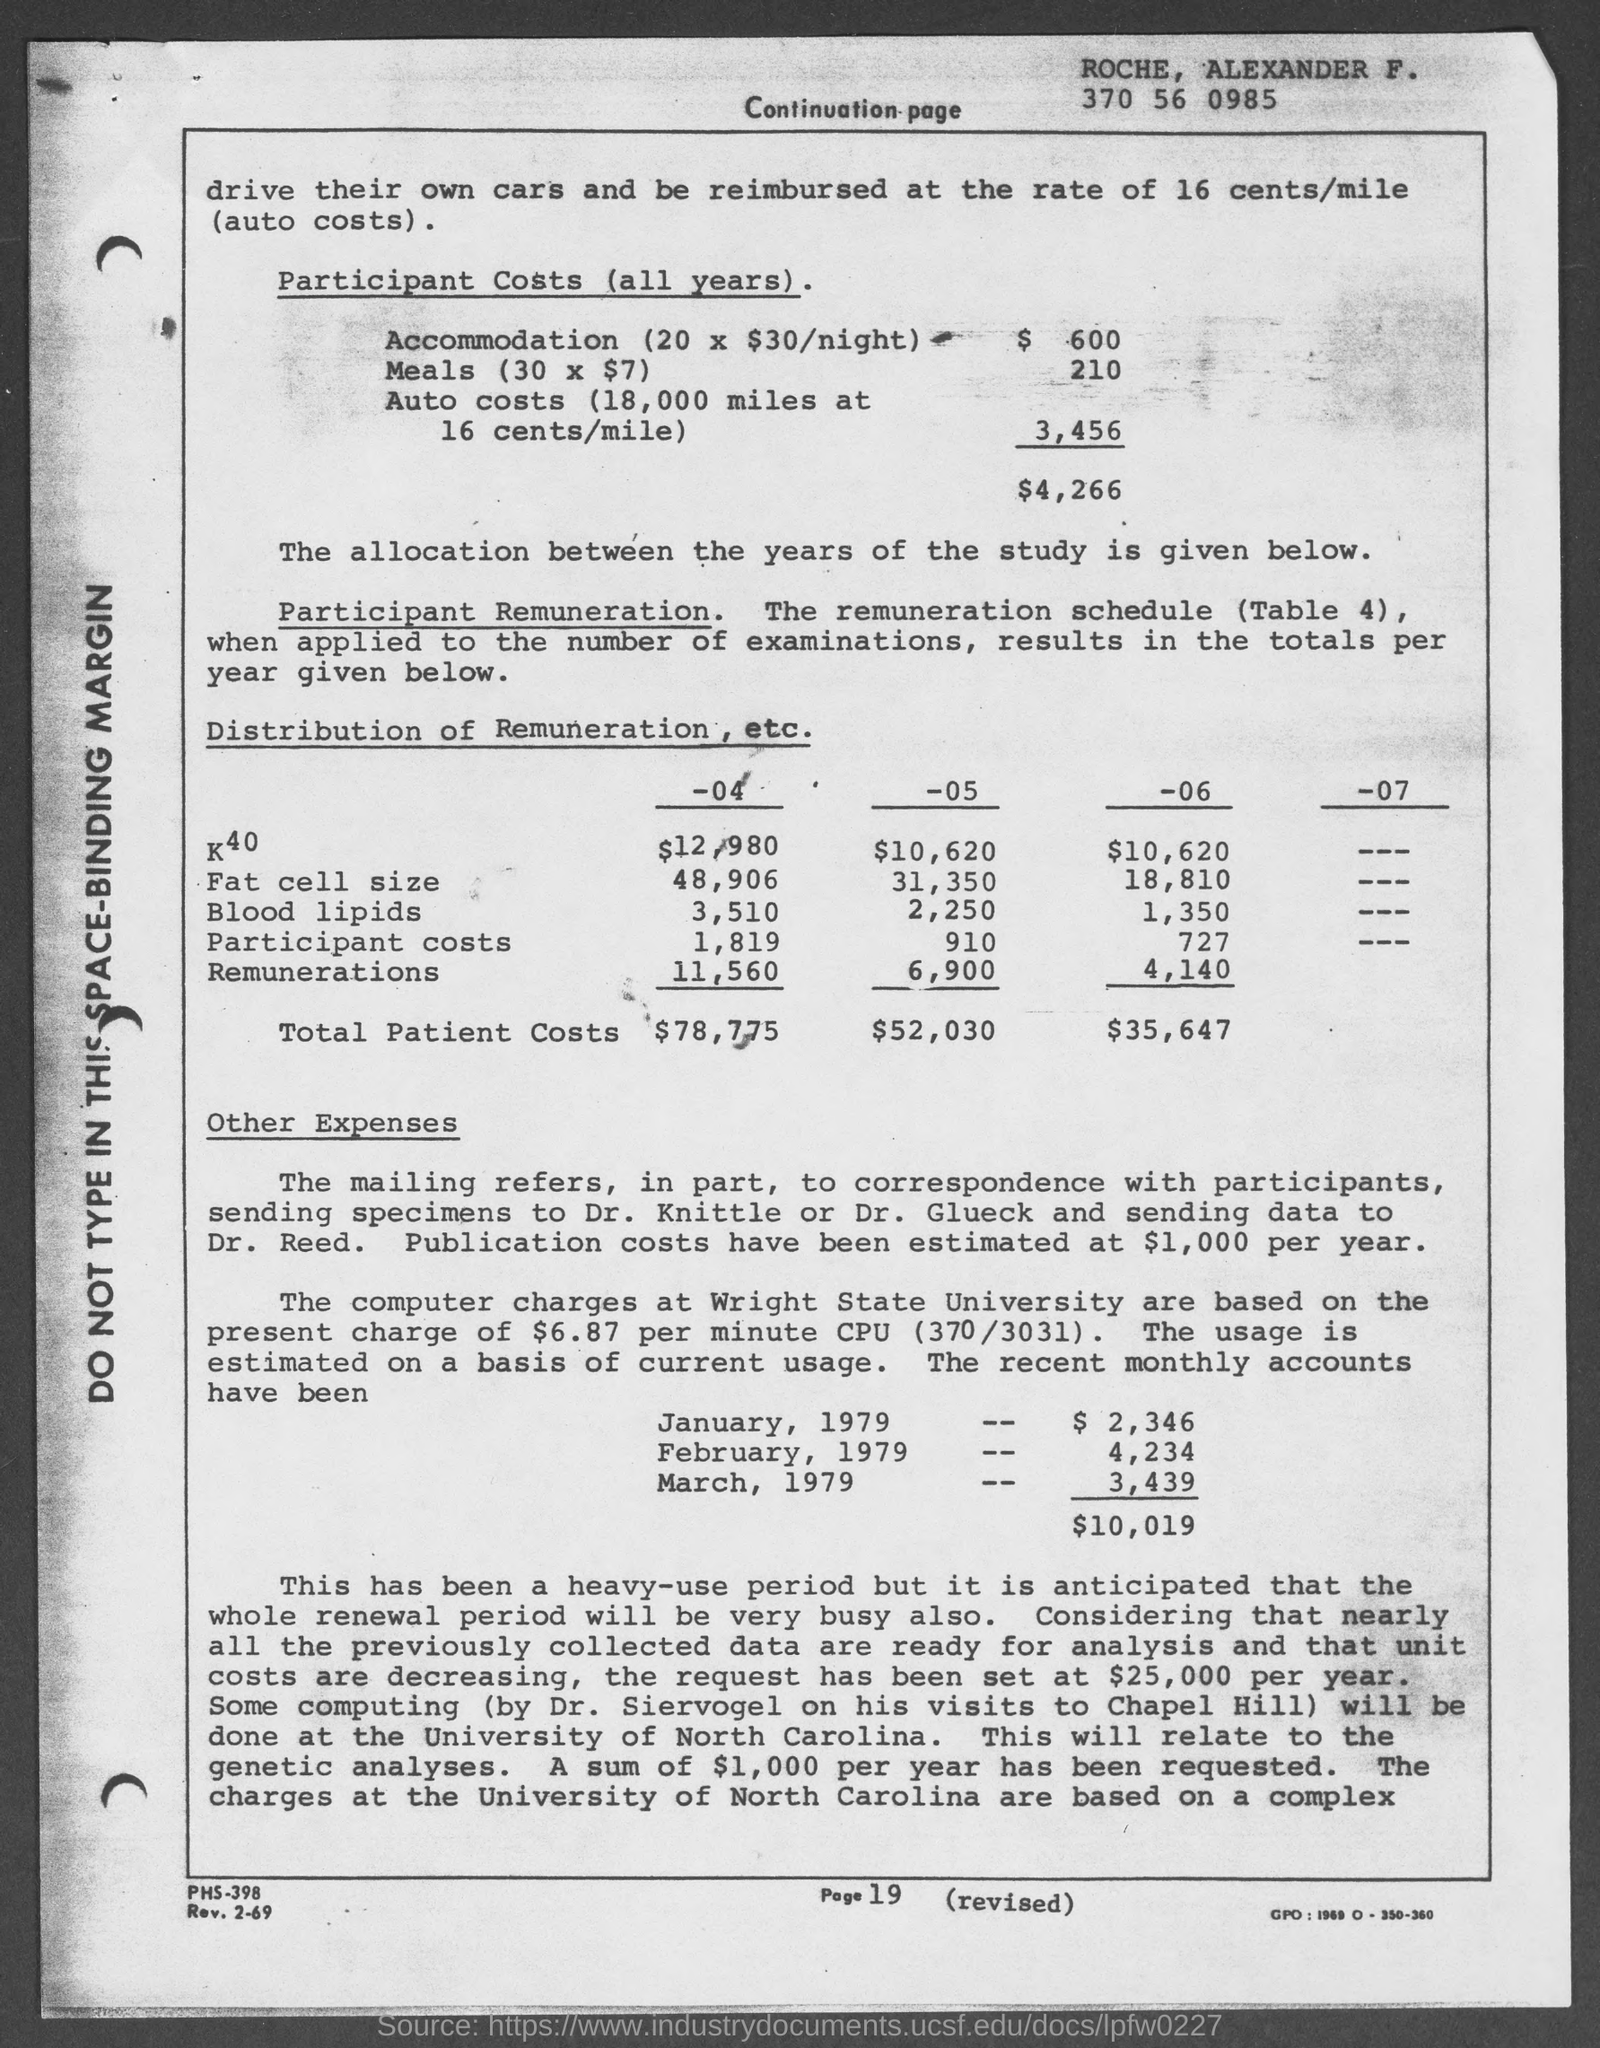What is the page number at bottom of the page?
Your response must be concise. 19. 